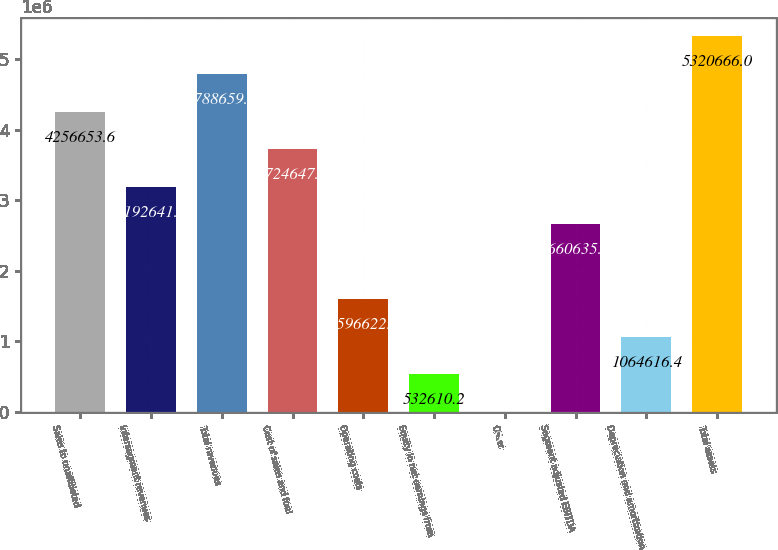Convert chart. <chart><loc_0><loc_0><loc_500><loc_500><bar_chart><fcel>Sales to unaffiliated<fcel>Intersegment revenues<fcel>Total revenues<fcel>Cost of sales and fuel<fcel>Operating costs<fcel>Equity in net earnings from<fcel>Other<fcel>Segment adjusted EBITDA<fcel>Depreciation and amortization<fcel>Total assets<nl><fcel>4.25665e+06<fcel>3.19264e+06<fcel>4.78866e+06<fcel>3.72465e+06<fcel>1.59662e+06<fcel>532610<fcel>604<fcel>2.66064e+06<fcel>1.06462e+06<fcel>5.32067e+06<nl></chart> 